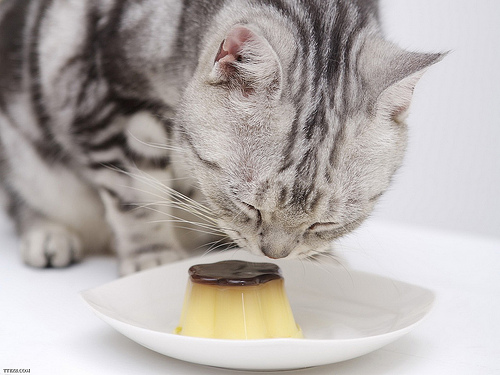Please provide the bounding box coordinate of the region this sentence describes: the cat ear is pink. The pink inner ear of the cat is located in the upper left of the frame, with bounding box coordinates approximately at [0.4, 0.17, 0.57, 0.32]. 